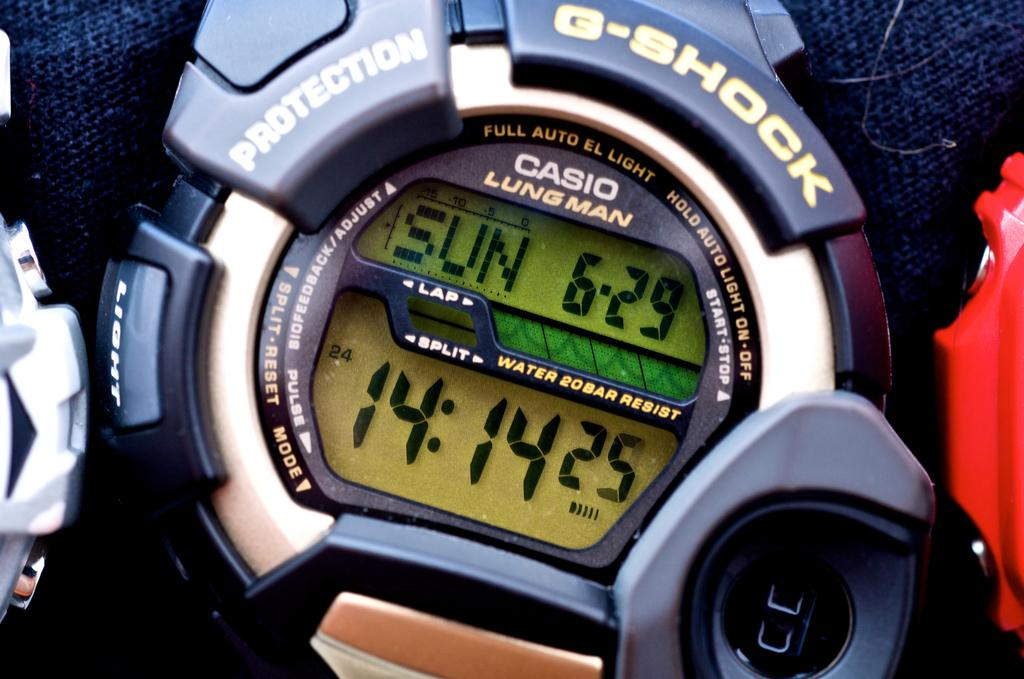<image>
Create a compact narrative representing the image presented. the face of a Casio, Lungman watch with some biometrics such as pulse. 